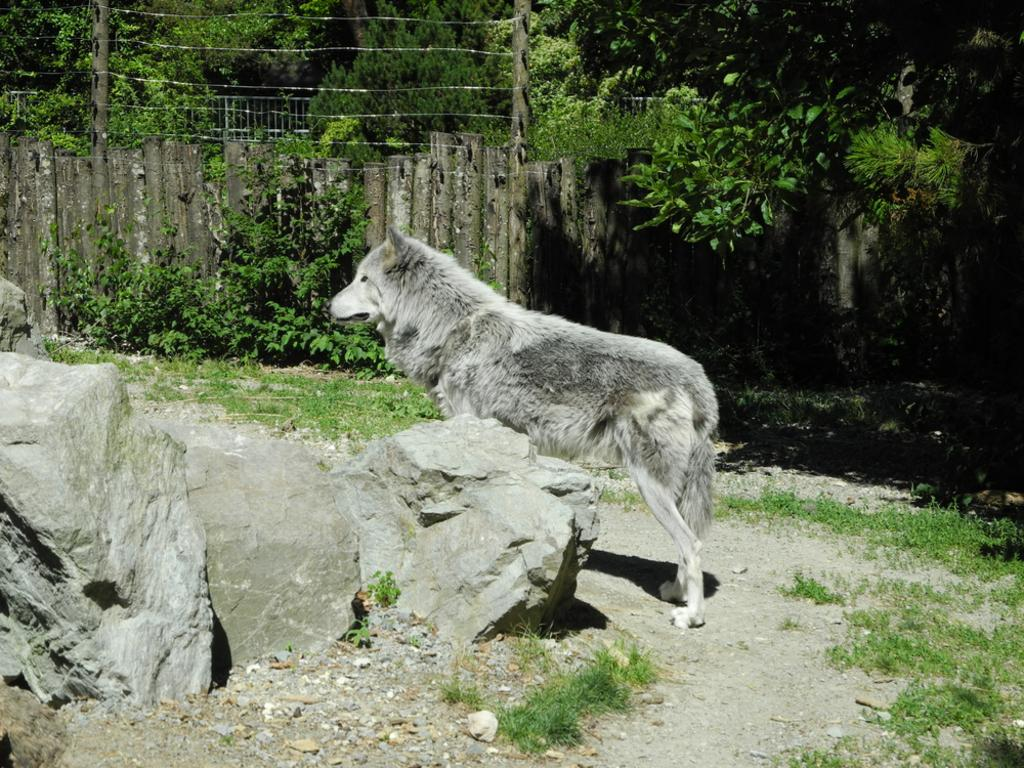What type of animal can be seen in the image? There is an animal in the image, but its specific type cannot be determined from the provided facts. What colors are present on the animal in the image? The animal is white and black in color. What type of terrain is visible in the image? There are stones, green grass, and trees visible in the image. What type of barrier is present in the image? There is fencing in the image. What type of vase can be seen in the hands of the animal in the image? There is no vase or hands present in the image; it features an animal, stones, green grass, trees, and fencing. 